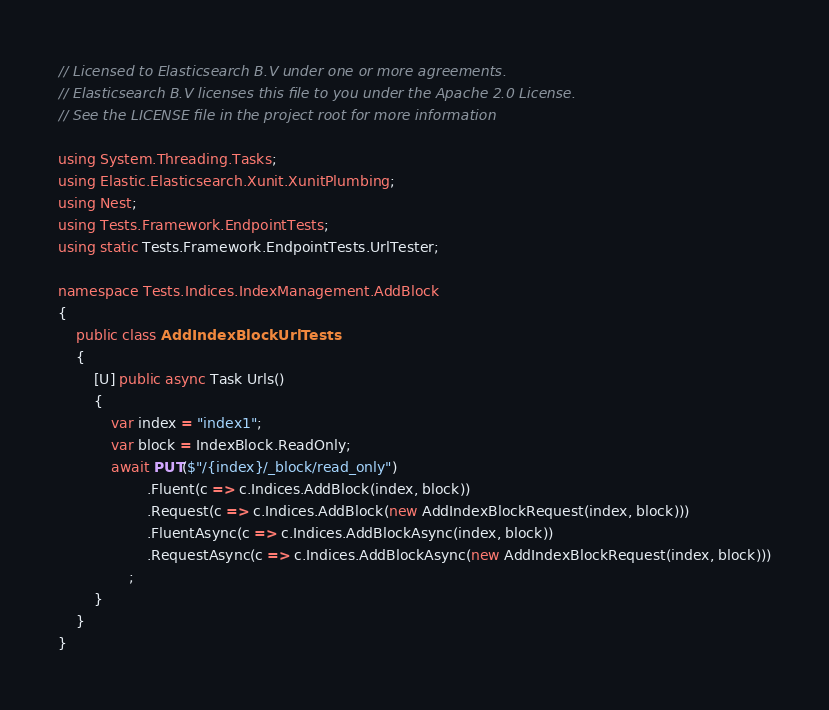Convert code to text. <code><loc_0><loc_0><loc_500><loc_500><_C#_>// Licensed to Elasticsearch B.V under one or more agreements.
// Elasticsearch B.V licenses this file to you under the Apache 2.0 License.
// See the LICENSE file in the project root for more information

using System.Threading.Tasks;
using Elastic.Elasticsearch.Xunit.XunitPlumbing;
using Nest;
using Tests.Framework.EndpointTests;
using static Tests.Framework.EndpointTests.UrlTester;

namespace Tests.Indices.IndexManagement.AddBlock
{
	public class AddIndexBlockUrlTests
	{
		[U] public async Task Urls()
		{
			var index = "index1";
			var block = IndexBlock.ReadOnly;
			await PUT($"/{index}/_block/read_only")
					.Fluent(c => c.Indices.AddBlock(index, block))
					.Request(c => c.Indices.AddBlock(new AddIndexBlockRequest(index, block)))
					.FluentAsync(c => c.Indices.AddBlockAsync(index, block))
					.RequestAsync(c => c.Indices.AddBlockAsync(new AddIndexBlockRequest(index, block)))
				;
		}
	}
}
</code> 